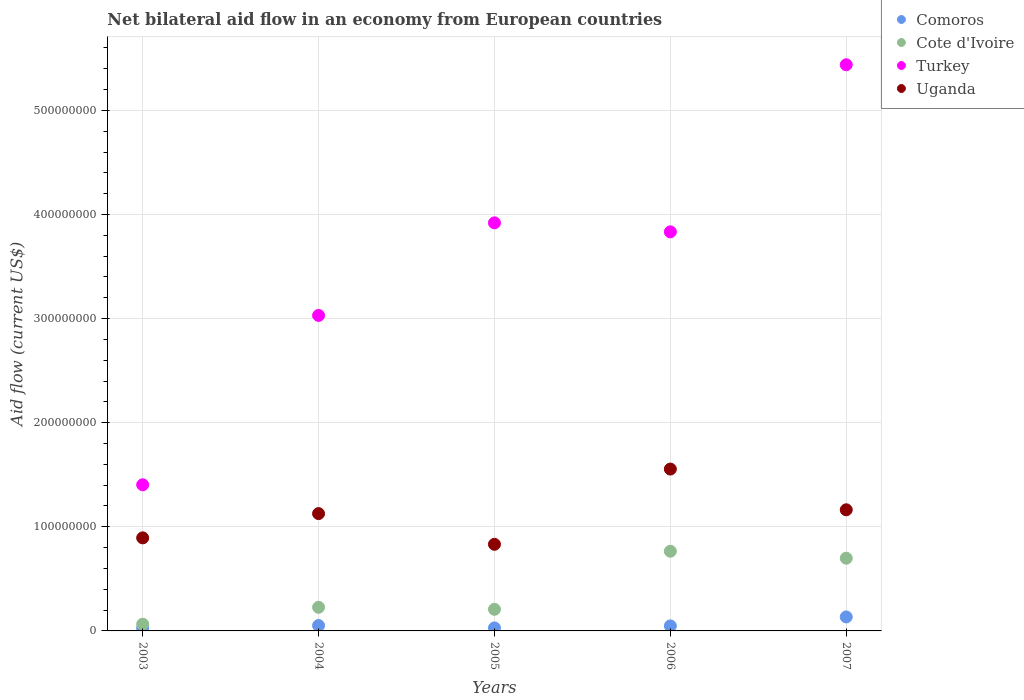What is the net bilateral aid flow in Cote d'Ivoire in 2003?
Make the answer very short. 6.45e+06. Across all years, what is the maximum net bilateral aid flow in Uganda?
Your answer should be compact. 1.55e+08. Across all years, what is the minimum net bilateral aid flow in Cote d'Ivoire?
Give a very brief answer. 6.45e+06. In which year was the net bilateral aid flow in Uganda maximum?
Your response must be concise. 2006. What is the total net bilateral aid flow in Turkey in the graph?
Your answer should be very brief. 1.76e+09. What is the difference between the net bilateral aid flow in Cote d'Ivoire in 2004 and that in 2006?
Provide a short and direct response. -5.38e+07. What is the difference between the net bilateral aid flow in Comoros in 2004 and the net bilateral aid flow in Turkey in 2003?
Ensure brevity in your answer.  -1.35e+08. What is the average net bilateral aid flow in Cote d'Ivoire per year?
Your answer should be compact. 3.93e+07. In the year 2005, what is the difference between the net bilateral aid flow in Turkey and net bilateral aid flow in Cote d'Ivoire?
Your answer should be compact. 3.71e+08. What is the ratio of the net bilateral aid flow in Cote d'Ivoire in 2004 to that in 2006?
Ensure brevity in your answer.  0.3. What is the difference between the highest and the second highest net bilateral aid flow in Cote d'Ivoire?
Make the answer very short. 6.69e+06. What is the difference between the highest and the lowest net bilateral aid flow in Turkey?
Ensure brevity in your answer.  4.03e+08. In how many years, is the net bilateral aid flow in Comoros greater than the average net bilateral aid flow in Comoros taken over all years?
Your answer should be compact. 1. Is it the case that in every year, the sum of the net bilateral aid flow in Comoros and net bilateral aid flow in Turkey  is greater than the sum of net bilateral aid flow in Cote d'Ivoire and net bilateral aid flow in Uganda?
Your response must be concise. Yes. Is the net bilateral aid flow in Comoros strictly greater than the net bilateral aid flow in Uganda over the years?
Your response must be concise. No. Is the net bilateral aid flow in Cote d'Ivoire strictly less than the net bilateral aid flow in Turkey over the years?
Provide a succinct answer. Yes. How many dotlines are there?
Offer a very short reply. 4. How many years are there in the graph?
Your answer should be compact. 5. What is the difference between two consecutive major ticks on the Y-axis?
Give a very brief answer. 1.00e+08. Are the values on the major ticks of Y-axis written in scientific E-notation?
Give a very brief answer. No. Does the graph contain any zero values?
Give a very brief answer. No. Where does the legend appear in the graph?
Keep it short and to the point. Top right. How are the legend labels stacked?
Keep it short and to the point. Vertical. What is the title of the graph?
Make the answer very short. Net bilateral aid flow in an economy from European countries. Does "Guatemala" appear as one of the legend labels in the graph?
Your response must be concise. No. What is the Aid flow (current US$) of Comoros in 2003?
Your answer should be very brief. 2.58e+06. What is the Aid flow (current US$) in Cote d'Ivoire in 2003?
Offer a terse response. 6.45e+06. What is the Aid flow (current US$) in Turkey in 2003?
Ensure brevity in your answer.  1.40e+08. What is the Aid flow (current US$) in Uganda in 2003?
Your response must be concise. 8.94e+07. What is the Aid flow (current US$) in Comoros in 2004?
Offer a terse response. 5.19e+06. What is the Aid flow (current US$) in Cote d'Ivoire in 2004?
Your answer should be compact. 2.27e+07. What is the Aid flow (current US$) in Turkey in 2004?
Keep it short and to the point. 3.03e+08. What is the Aid flow (current US$) in Uganda in 2004?
Offer a terse response. 1.13e+08. What is the Aid flow (current US$) of Comoros in 2005?
Ensure brevity in your answer.  2.88e+06. What is the Aid flow (current US$) of Cote d'Ivoire in 2005?
Offer a very short reply. 2.08e+07. What is the Aid flow (current US$) of Turkey in 2005?
Your response must be concise. 3.92e+08. What is the Aid flow (current US$) in Uganda in 2005?
Make the answer very short. 8.32e+07. What is the Aid flow (current US$) of Comoros in 2006?
Provide a succinct answer. 4.81e+06. What is the Aid flow (current US$) in Cote d'Ivoire in 2006?
Offer a very short reply. 7.65e+07. What is the Aid flow (current US$) of Turkey in 2006?
Offer a terse response. 3.83e+08. What is the Aid flow (current US$) of Uganda in 2006?
Your answer should be compact. 1.55e+08. What is the Aid flow (current US$) of Comoros in 2007?
Make the answer very short. 1.34e+07. What is the Aid flow (current US$) of Cote d'Ivoire in 2007?
Give a very brief answer. 6.98e+07. What is the Aid flow (current US$) of Turkey in 2007?
Provide a short and direct response. 5.44e+08. What is the Aid flow (current US$) of Uganda in 2007?
Ensure brevity in your answer.  1.16e+08. Across all years, what is the maximum Aid flow (current US$) of Comoros?
Provide a short and direct response. 1.34e+07. Across all years, what is the maximum Aid flow (current US$) in Cote d'Ivoire?
Keep it short and to the point. 7.65e+07. Across all years, what is the maximum Aid flow (current US$) in Turkey?
Provide a succinct answer. 5.44e+08. Across all years, what is the maximum Aid flow (current US$) of Uganda?
Offer a terse response. 1.55e+08. Across all years, what is the minimum Aid flow (current US$) of Comoros?
Your response must be concise. 2.58e+06. Across all years, what is the minimum Aid flow (current US$) in Cote d'Ivoire?
Provide a succinct answer. 6.45e+06. Across all years, what is the minimum Aid flow (current US$) of Turkey?
Provide a short and direct response. 1.40e+08. Across all years, what is the minimum Aid flow (current US$) in Uganda?
Ensure brevity in your answer.  8.32e+07. What is the total Aid flow (current US$) of Comoros in the graph?
Give a very brief answer. 2.89e+07. What is the total Aid flow (current US$) of Cote d'Ivoire in the graph?
Your response must be concise. 1.96e+08. What is the total Aid flow (current US$) of Turkey in the graph?
Ensure brevity in your answer.  1.76e+09. What is the total Aid flow (current US$) of Uganda in the graph?
Provide a short and direct response. 5.57e+08. What is the difference between the Aid flow (current US$) of Comoros in 2003 and that in 2004?
Keep it short and to the point. -2.61e+06. What is the difference between the Aid flow (current US$) in Cote d'Ivoire in 2003 and that in 2004?
Offer a very short reply. -1.62e+07. What is the difference between the Aid flow (current US$) of Turkey in 2003 and that in 2004?
Ensure brevity in your answer.  -1.63e+08. What is the difference between the Aid flow (current US$) in Uganda in 2003 and that in 2004?
Ensure brevity in your answer.  -2.33e+07. What is the difference between the Aid flow (current US$) in Comoros in 2003 and that in 2005?
Provide a succinct answer. -3.00e+05. What is the difference between the Aid flow (current US$) in Cote d'Ivoire in 2003 and that in 2005?
Give a very brief answer. -1.43e+07. What is the difference between the Aid flow (current US$) of Turkey in 2003 and that in 2005?
Provide a short and direct response. -2.52e+08. What is the difference between the Aid flow (current US$) of Uganda in 2003 and that in 2005?
Keep it short and to the point. 6.18e+06. What is the difference between the Aid flow (current US$) of Comoros in 2003 and that in 2006?
Keep it short and to the point. -2.23e+06. What is the difference between the Aid flow (current US$) in Cote d'Ivoire in 2003 and that in 2006?
Offer a terse response. -7.01e+07. What is the difference between the Aid flow (current US$) in Turkey in 2003 and that in 2006?
Give a very brief answer. -2.43e+08. What is the difference between the Aid flow (current US$) in Uganda in 2003 and that in 2006?
Your answer should be compact. -6.61e+07. What is the difference between the Aid flow (current US$) in Comoros in 2003 and that in 2007?
Ensure brevity in your answer.  -1.09e+07. What is the difference between the Aid flow (current US$) in Cote d'Ivoire in 2003 and that in 2007?
Offer a terse response. -6.34e+07. What is the difference between the Aid flow (current US$) of Turkey in 2003 and that in 2007?
Make the answer very short. -4.03e+08. What is the difference between the Aid flow (current US$) of Uganda in 2003 and that in 2007?
Your response must be concise. -2.70e+07. What is the difference between the Aid flow (current US$) in Comoros in 2004 and that in 2005?
Your response must be concise. 2.31e+06. What is the difference between the Aid flow (current US$) of Cote d'Ivoire in 2004 and that in 2005?
Your answer should be very brief. 1.94e+06. What is the difference between the Aid flow (current US$) in Turkey in 2004 and that in 2005?
Your answer should be very brief. -8.89e+07. What is the difference between the Aid flow (current US$) in Uganda in 2004 and that in 2005?
Offer a very short reply. 2.95e+07. What is the difference between the Aid flow (current US$) of Cote d'Ivoire in 2004 and that in 2006?
Give a very brief answer. -5.38e+07. What is the difference between the Aid flow (current US$) of Turkey in 2004 and that in 2006?
Your answer should be compact. -8.03e+07. What is the difference between the Aid flow (current US$) of Uganda in 2004 and that in 2006?
Keep it short and to the point. -4.28e+07. What is the difference between the Aid flow (current US$) of Comoros in 2004 and that in 2007?
Give a very brief answer. -8.25e+06. What is the difference between the Aid flow (current US$) of Cote d'Ivoire in 2004 and that in 2007?
Make the answer very short. -4.72e+07. What is the difference between the Aid flow (current US$) in Turkey in 2004 and that in 2007?
Offer a very short reply. -2.41e+08. What is the difference between the Aid flow (current US$) of Uganda in 2004 and that in 2007?
Your answer should be very brief. -3.66e+06. What is the difference between the Aid flow (current US$) in Comoros in 2005 and that in 2006?
Offer a very short reply. -1.93e+06. What is the difference between the Aid flow (current US$) of Cote d'Ivoire in 2005 and that in 2006?
Provide a short and direct response. -5.58e+07. What is the difference between the Aid flow (current US$) of Turkey in 2005 and that in 2006?
Give a very brief answer. 8.64e+06. What is the difference between the Aid flow (current US$) in Uganda in 2005 and that in 2006?
Offer a very short reply. -7.23e+07. What is the difference between the Aid flow (current US$) in Comoros in 2005 and that in 2007?
Give a very brief answer. -1.06e+07. What is the difference between the Aid flow (current US$) in Cote d'Ivoire in 2005 and that in 2007?
Make the answer very short. -4.91e+07. What is the difference between the Aid flow (current US$) in Turkey in 2005 and that in 2007?
Your answer should be very brief. -1.52e+08. What is the difference between the Aid flow (current US$) in Uganda in 2005 and that in 2007?
Offer a very short reply. -3.32e+07. What is the difference between the Aid flow (current US$) of Comoros in 2006 and that in 2007?
Your answer should be very brief. -8.63e+06. What is the difference between the Aid flow (current US$) in Cote d'Ivoire in 2006 and that in 2007?
Your answer should be very brief. 6.69e+06. What is the difference between the Aid flow (current US$) of Turkey in 2006 and that in 2007?
Provide a succinct answer. -1.60e+08. What is the difference between the Aid flow (current US$) in Uganda in 2006 and that in 2007?
Your answer should be compact. 3.91e+07. What is the difference between the Aid flow (current US$) in Comoros in 2003 and the Aid flow (current US$) in Cote d'Ivoire in 2004?
Keep it short and to the point. -2.01e+07. What is the difference between the Aid flow (current US$) of Comoros in 2003 and the Aid flow (current US$) of Turkey in 2004?
Give a very brief answer. -3.00e+08. What is the difference between the Aid flow (current US$) of Comoros in 2003 and the Aid flow (current US$) of Uganda in 2004?
Give a very brief answer. -1.10e+08. What is the difference between the Aid flow (current US$) of Cote d'Ivoire in 2003 and the Aid flow (current US$) of Turkey in 2004?
Give a very brief answer. -2.97e+08. What is the difference between the Aid flow (current US$) in Cote d'Ivoire in 2003 and the Aid flow (current US$) in Uganda in 2004?
Make the answer very short. -1.06e+08. What is the difference between the Aid flow (current US$) in Turkey in 2003 and the Aid flow (current US$) in Uganda in 2004?
Provide a short and direct response. 2.77e+07. What is the difference between the Aid flow (current US$) of Comoros in 2003 and the Aid flow (current US$) of Cote d'Ivoire in 2005?
Make the answer very short. -1.82e+07. What is the difference between the Aid flow (current US$) of Comoros in 2003 and the Aid flow (current US$) of Turkey in 2005?
Give a very brief answer. -3.89e+08. What is the difference between the Aid flow (current US$) of Comoros in 2003 and the Aid flow (current US$) of Uganda in 2005?
Provide a succinct answer. -8.06e+07. What is the difference between the Aid flow (current US$) of Cote d'Ivoire in 2003 and the Aid flow (current US$) of Turkey in 2005?
Give a very brief answer. -3.86e+08. What is the difference between the Aid flow (current US$) of Cote d'Ivoire in 2003 and the Aid flow (current US$) of Uganda in 2005?
Your answer should be compact. -7.68e+07. What is the difference between the Aid flow (current US$) in Turkey in 2003 and the Aid flow (current US$) in Uganda in 2005?
Offer a very short reply. 5.72e+07. What is the difference between the Aid flow (current US$) of Comoros in 2003 and the Aid flow (current US$) of Cote d'Ivoire in 2006?
Offer a very short reply. -7.40e+07. What is the difference between the Aid flow (current US$) of Comoros in 2003 and the Aid flow (current US$) of Turkey in 2006?
Offer a terse response. -3.81e+08. What is the difference between the Aid flow (current US$) in Comoros in 2003 and the Aid flow (current US$) in Uganda in 2006?
Your response must be concise. -1.53e+08. What is the difference between the Aid flow (current US$) in Cote d'Ivoire in 2003 and the Aid flow (current US$) in Turkey in 2006?
Provide a succinct answer. -3.77e+08. What is the difference between the Aid flow (current US$) in Cote d'Ivoire in 2003 and the Aid flow (current US$) in Uganda in 2006?
Keep it short and to the point. -1.49e+08. What is the difference between the Aid flow (current US$) of Turkey in 2003 and the Aid flow (current US$) of Uganda in 2006?
Provide a short and direct response. -1.51e+07. What is the difference between the Aid flow (current US$) of Comoros in 2003 and the Aid flow (current US$) of Cote d'Ivoire in 2007?
Keep it short and to the point. -6.73e+07. What is the difference between the Aid flow (current US$) in Comoros in 2003 and the Aid flow (current US$) in Turkey in 2007?
Provide a short and direct response. -5.41e+08. What is the difference between the Aid flow (current US$) in Comoros in 2003 and the Aid flow (current US$) in Uganda in 2007?
Offer a terse response. -1.14e+08. What is the difference between the Aid flow (current US$) in Cote d'Ivoire in 2003 and the Aid flow (current US$) in Turkey in 2007?
Provide a succinct answer. -5.37e+08. What is the difference between the Aid flow (current US$) in Cote d'Ivoire in 2003 and the Aid flow (current US$) in Uganda in 2007?
Provide a short and direct response. -1.10e+08. What is the difference between the Aid flow (current US$) of Turkey in 2003 and the Aid flow (current US$) of Uganda in 2007?
Ensure brevity in your answer.  2.40e+07. What is the difference between the Aid flow (current US$) of Comoros in 2004 and the Aid flow (current US$) of Cote d'Ivoire in 2005?
Offer a very short reply. -1.56e+07. What is the difference between the Aid flow (current US$) of Comoros in 2004 and the Aid flow (current US$) of Turkey in 2005?
Make the answer very short. -3.87e+08. What is the difference between the Aid flow (current US$) in Comoros in 2004 and the Aid flow (current US$) in Uganda in 2005?
Your response must be concise. -7.80e+07. What is the difference between the Aid flow (current US$) of Cote d'Ivoire in 2004 and the Aid flow (current US$) of Turkey in 2005?
Give a very brief answer. -3.69e+08. What is the difference between the Aid flow (current US$) of Cote d'Ivoire in 2004 and the Aid flow (current US$) of Uganda in 2005?
Your answer should be compact. -6.05e+07. What is the difference between the Aid flow (current US$) of Turkey in 2004 and the Aid flow (current US$) of Uganda in 2005?
Ensure brevity in your answer.  2.20e+08. What is the difference between the Aid flow (current US$) of Comoros in 2004 and the Aid flow (current US$) of Cote d'Ivoire in 2006?
Give a very brief answer. -7.14e+07. What is the difference between the Aid flow (current US$) of Comoros in 2004 and the Aid flow (current US$) of Turkey in 2006?
Keep it short and to the point. -3.78e+08. What is the difference between the Aid flow (current US$) in Comoros in 2004 and the Aid flow (current US$) in Uganda in 2006?
Provide a succinct answer. -1.50e+08. What is the difference between the Aid flow (current US$) in Cote d'Ivoire in 2004 and the Aid flow (current US$) in Turkey in 2006?
Your response must be concise. -3.61e+08. What is the difference between the Aid flow (current US$) in Cote d'Ivoire in 2004 and the Aid flow (current US$) in Uganda in 2006?
Give a very brief answer. -1.33e+08. What is the difference between the Aid flow (current US$) of Turkey in 2004 and the Aid flow (current US$) of Uganda in 2006?
Offer a terse response. 1.48e+08. What is the difference between the Aid flow (current US$) of Comoros in 2004 and the Aid flow (current US$) of Cote d'Ivoire in 2007?
Offer a very short reply. -6.47e+07. What is the difference between the Aid flow (current US$) in Comoros in 2004 and the Aid flow (current US$) in Turkey in 2007?
Your answer should be compact. -5.39e+08. What is the difference between the Aid flow (current US$) in Comoros in 2004 and the Aid flow (current US$) in Uganda in 2007?
Ensure brevity in your answer.  -1.11e+08. What is the difference between the Aid flow (current US$) of Cote d'Ivoire in 2004 and the Aid flow (current US$) of Turkey in 2007?
Provide a short and direct response. -5.21e+08. What is the difference between the Aid flow (current US$) of Cote d'Ivoire in 2004 and the Aid flow (current US$) of Uganda in 2007?
Provide a succinct answer. -9.37e+07. What is the difference between the Aid flow (current US$) in Turkey in 2004 and the Aid flow (current US$) in Uganda in 2007?
Offer a very short reply. 1.87e+08. What is the difference between the Aid flow (current US$) of Comoros in 2005 and the Aid flow (current US$) of Cote d'Ivoire in 2006?
Keep it short and to the point. -7.37e+07. What is the difference between the Aid flow (current US$) in Comoros in 2005 and the Aid flow (current US$) in Turkey in 2006?
Offer a very short reply. -3.80e+08. What is the difference between the Aid flow (current US$) of Comoros in 2005 and the Aid flow (current US$) of Uganda in 2006?
Your answer should be very brief. -1.53e+08. What is the difference between the Aid flow (current US$) of Cote d'Ivoire in 2005 and the Aid flow (current US$) of Turkey in 2006?
Your answer should be compact. -3.63e+08. What is the difference between the Aid flow (current US$) in Cote d'Ivoire in 2005 and the Aid flow (current US$) in Uganda in 2006?
Offer a terse response. -1.35e+08. What is the difference between the Aid flow (current US$) of Turkey in 2005 and the Aid flow (current US$) of Uganda in 2006?
Ensure brevity in your answer.  2.37e+08. What is the difference between the Aid flow (current US$) in Comoros in 2005 and the Aid flow (current US$) in Cote d'Ivoire in 2007?
Your answer should be very brief. -6.70e+07. What is the difference between the Aid flow (current US$) in Comoros in 2005 and the Aid flow (current US$) in Turkey in 2007?
Make the answer very short. -5.41e+08. What is the difference between the Aid flow (current US$) in Comoros in 2005 and the Aid flow (current US$) in Uganda in 2007?
Give a very brief answer. -1.13e+08. What is the difference between the Aid flow (current US$) in Cote d'Ivoire in 2005 and the Aid flow (current US$) in Turkey in 2007?
Give a very brief answer. -5.23e+08. What is the difference between the Aid flow (current US$) in Cote d'Ivoire in 2005 and the Aid flow (current US$) in Uganda in 2007?
Provide a succinct answer. -9.56e+07. What is the difference between the Aid flow (current US$) in Turkey in 2005 and the Aid flow (current US$) in Uganda in 2007?
Provide a succinct answer. 2.76e+08. What is the difference between the Aid flow (current US$) of Comoros in 2006 and the Aid flow (current US$) of Cote d'Ivoire in 2007?
Your response must be concise. -6.50e+07. What is the difference between the Aid flow (current US$) in Comoros in 2006 and the Aid flow (current US$) in Turkey in 2007?
Provide a succinct answer. -5.39e+08. What is the difference between the Aid flow (current US$) of Comoros in 2006 and the Aid flow (current US$) of Uganda in 2007?
Provide a short and direct response. -1.12e+08. What is the difference between the Aid flow (current US$) of Cote d'Ivoire in 2006 and the Aid flow (current US$) of Turkey in 2007?
Provide a succinct answer. -4.67e+08. What is the difference between the Aid flow (current US$) in Cote d'Ivoire in 2006 and the Aid flow (current US$) in Uganda in 2007?
Ensure brevity in your answer.  -3.98e+07. What is the difference between the Aid flow (current US$) in Turkey in 2006 and the Aid flow (current US$) in Uganda in 2007?
Your answer should be compact. 2.67e+08. What is the average Aid flow (current US$) of Comoros per year?
Ensure brevity in your answer.  5.78e+06. What is the average Aid flow (current US$) of Cote d'Ivoire per year?
Give a very brief answer. 3.93e+07. What is the average Aid flow (current US$) in Turkey per year?
Provide a succinct answer. 3.53e+08. What is the average Aid flow (current US$) of Uganda per year?
Your answer should be compact. 1.11e+08. In the year 2003, what is the difference between the Aid flow (current US$) of Comoros and Aid flow (current US$) of Cote d'Ivoire?
Give a very brief answer. -3.87e+06. In the year 2003, what is the difference between the Aid flow (current US$) in Comoros and Aid flow (current US$) in Turkey?
Your answer should be compact. -1.38e+08. In the year 2003, what is the difference between the Aid flow (current US$) of Comoros and Aid flow (current US$) of Uganda?
Keep it short and to the point. -8.68e+07. In the year 2003, what is the difference between the Aid flow (current US$) of Cote d'Ivoire and Aid flow (current US$) of Turkey?
Your response must be concise. -1.34e+08. In the year 2003, what is the difference between the Aid flow (current US$) in Cote d'Ivoire and Aid flow (current US$) in Uganda?
Your answer should be compact. -8.29e+07. In the year 2003, what is the difference between the Aid flow (current US$) of Turkey and Aid flow (current US$) of Uganda?
Give a very brief answer. 5.10e+07. In the year 2004, what is the difference between the Aid flow (current US$) in Comoros and Aid flow (current US$) in Cote d'Ivoire?
Your response must be concise. -1.75e+07. In the year 2004, what is the difference between the Aid flow (current US$) in Comoros and Aid flow (current US$) in Turkey?
Offer a very short reply. -2.98e+08. In the year 2004, what is the difference between the Aid flow (current US$) of Comoros and Aid flow (current US$) of Uganda?
Offer a terse response. -1.08e+08. In the year 2004, what is the difference between the Aid flow (current US$) of Cote d'Ivoire and Aid flow (current US$) of Turkey?
Make the answer very short. -2.80e+08. In the year 2004, what is the difference between the Aid flow (current US$) of Cote d'Ivoire and Aid flow (current US$) of Uganda?
Give a very brief answer. -9.00e+07. In the year 2004, what is the difference between the Aid flow (current US$) of Turkey and Aid flow (current US$) of Uganda?
Provide a succinct answer. 1.90e+08. In the year 2005, what is the difference between the Aid flow (current US$) in Comoros and Aid flow (current US$) in Cote d'Ivoire?
Your answer should be very brief. -1.79e+07. In the year 2005, what is the difference between the Aid flow (current US$) of Comoros and Aid flow (current US$) of Turkey?
Offer a terse response. -3.89e+08. In the year 2005, what is the difference between the Aid flow (current US$) in Comoros and Aid flow (current US$) in Uganda?
Your answer should be very brief. -8.03e+07. In the year 2005, what is the difference between the Aid flow (current US$) of Cote d'Ivoire and Aid flow (current US$) of Turkey?
Provide a short and direct response. -3.71e+08. In the year 2005, what is the difference between the Aid flow (current US$) of Cote d'Ivoire and Aid flow (current US$) of Uganda?
Make the answer very short. -6.24e+07. In the year 2005, what is the difference between the Aid flow (current US$) in Turkey and Aid flow (current US$) in Uganda?
Make the answer very short. 3.09e+08. In the year 2006, what is the difference between the Aid flow (current US$) in Comoros and Aid flow (current US$) in Cote d'Ivoire?
Ensure brevity in your answer.  -7.17e+07. In the year 2006, what is the difference between the Aid flow (current US$) in Comoros and Aid flow (current US$) in Turkey?
Offer a very short reply. -3.79e+08. In the year 2006, what is the difference between the Aid flow (current US$) in Comoros and Aid flow (current US$) in Uganda?
Make the answer very short. -1.51e+08. In the year 2006, what is the difference between the Aid flow (current US$) in Cote d'Ivoire and Aid flow (current US$) in Turkey?
Your response must be concise. -3.07e+08. In the year 2006, what is the difference between the Aid flow (current US$) in Cote d'Ivoire and Aid flow (current US$) in Uganda?
Provide a succinct answer. -7.89e+07. In the year 2006, what is the difference between the Aid flow (current US$) of Turkey and Aid flow (current US$) of Uganda?
Give a very brief answer. 2.28e+08. In the year 2007, what is the difference between the Aid flow (current US$) in Comoros and Aid flow (current US$) in Cote d'Ivoire?
Your response must be concise. -5.64e+07. In the year 2007, what is the difference between the Aid flow (current US$) in Comoros and Aid flow (current US$) in Turkey?
Keep it short and to the point. -5.30e+08. In the year 2007, what is the difference between the Aid flow (current US$) in Comoros and Aid flow (current US$) in Uganda?
Offer a terse response. -1.03e+08. In the year 2007, what is the difference between the Aid flow (current US$) of Cote d'Ivoire and Aid flow (current US$) of Turkey?
Give a very brief answer. -4.74e+08. In the year 2007, what is the difference between the Aid flow (current US$) in Cote d'Ivoire and Aid flow (current US$) in Uganda?
Provide a succinct answer. -4.65e+07. In the year 2007, what is the difference between the Aid flow (current US$) of Turkey and Aid flow (current US$) of Uganda?
Your response must be concise. 4.27e+08. What is the ratio of the Aid flow (current US$) in Comoros in 2003 to that in 2004?
Provide a short and direct response. 0.5. What is the ratio of the Aid flow (current US$) of Cote d'Ivoire in 2003 to that in 2004?
Your answer should be very brief. 0.28. What is the ratio of the Aid flow (current US$) of Turkey in 2003 to that in 2004?
Provide a succinct answer. 0.46. What is the ratio of the Aid flow (current US$) of Uganda in 2003 to that in 2004?
Your response must be concise. 0.79. What is the ratio of the Aid flow (current US$) in Comoros in 2003 to that in 2005?
Offer a terse response. 0.9. What is the ratio of the Aid flow (current US$) of Cote d'Ivoire in 2003 to that in 2005?
Provide a short and direct response. 0.31. What is the ratio of the Aid flow (current US$) of Turkey in 2003 to that in 2005?
Your response must be concise. 0.36. What is the ratio of the Aid flow (current US$) of Uganda in 2003 to that in 2005?
Keep it short and to the point. 1.07. What is the ratio of the Aid flow (current US$) of Comoros in 2003 to that in 2006?
Give a very brief answer. 0.54. What is the ratio of the Aid flow (current US$) of Cote d'Ivoire in 2003 to that in 2006?
Ensure brevity in your answer.  0.08. What is the ratio of the Aid flow (current US$) of Turkey in 2003 to that in 2006?
Your answer should be very brief. 0.37. What is the ratio of the Aid flow (current US$) of Uganda in 2003 to that in 2006?
Your answer should be compact. 0.57. What is the ratio of the Aid flow (current US$) in Comoros in 2003 to that in 2007?
Keep it short and to the point. 0.19. What is the ratio of the Aid flow (current US$) of Cote d'Ivoire in 2003 to that in 2007?
Your answer should be compact. 0.09. What is the ratio of the Aid flow (current US$) in Turkey in 2003 to that in 2007?
Offer a terse response. 0.26. What is the ratio of the Aid flow (current US$) in Uganda in 2003 to that in 2007?
Ensure brevity in your answer.  0.77. What is the ratio of the Aid flow (current US$) in Comoros in 2004 to that in 2005?
Provide a succinct answer. 1.8. What is the ratio of the Aid flow (current US$) of Cote d'Ivoire in 2004 to that in 2005?
Your answer should be very brief. 1.09. What is the ratio of the Aid flow (current US$) of Turkey in 2004 to that in 2005?
Your answer should be very brief. 0.77. What is the ratio of the Aid flow (current US$) of Uganda in 2004 to that in 2005?
Give a very brief answer. 1.35. What is the ratio of the Aid flow (current US$) of Comoros in 2004 to that in 2006?
Give a very brief answer. 1.08. What is the ratio of the Aid flow (current US$) of Cote d'Ivoire in 2004 to that in 2006?
Keep it short and to the point. 0.3. What is the ratio of the Aid flow (current US$) in Turkey in 2004 to that in 2006?
Provide a short and direct response. 0.79. What is the ratio of the Aid flow (current US$) of Uganda in 2004 to that in 2006?
Make the answer very short. 0.72. What is the ratio of the Aid flow (current US$) in Comoros in 2004 to that in 2007?
Your response must be concise. 0.39. What is the ratio of the Aid flow (current US$) of Cote d'Ivoire in 2004 to that in 2007?
Provide a short and direct response. 0.32. What is the ratio of the Aid flow (current US$) of Turkey in 2004 to that in 2007?
Offer a very short reply. 0.56. What is the ratio of the Aid flow (current US$) of Uganda in 2004 to that in 2007?
Your answer should be very brief. 0.97. What is the ratio of the Aid flow (current US$) of Comoros in 2005 to that in 2006?
Offer a terse response. 0.6. What is the ratio of the Aid flow (current US$) of Cote d'Ivoire in 2005 to that in 2006?
Offer a very short reply. 0.27. What is the ratio of the Aid flow (current US$) in Turkey in 2005 to that in 2006?
Provide a succinct answer. 1.02. What is the ratio of the Aid flow (current US$) in Uganda in 2005 to that in 2006?
Your response must be concise. 0.54. What is the ratio of the Aid flow (current US$) of Comoros in 2005 to that in 2007?
Your answer should be compact. 0.21. What is the ratio of the Aid flow (current US$) in Cote d'Ivoire in 2005 to that in 2007?
Ensure brevity in your answer.  0.3. What is the ratio of the Aid flow (current US$) of Turkey in 2005 to that in 2007?
Give a very brief answer. 0.72. What is the ratio of the Aid flow (current US$) in Uganda in 2005 to that in 2007?
Offer a terse response. 0.72. What is the ratio of the Aid flow (current US$) in Comoros in 2006 to that in 2007?
Your response must be concise. 0.36. What is the ratio of the Aid flow (current US$) of Cote d'Ivoire in 2006 to that in 2007?
Offer a very short reply. 1.1. What is the ratio of the Aid flow (current US$) of Turkey in 2006 to that in 2007?
Your response must be concise. 0.7. What is the ratio of the Aid flow (current US$) in Uganda in 2006 to that in 2007?
Offer a terse response. 1.34. What is the difference between the highest and the second highest Aid flow (current US$) of Comoros?
Offer a terse response. 8.25e+06. What is the difference between the highest and the second highest Aid flow (current US$) of Cote d'Ivoire?
Keep it short and to the point. 6.69e+06. What is the difference between the highest and the second highest Aid flow (current US$) of Turkey?
Make the answer very short. 1.52e+08. What is the difference between the highest and the second highest Aid flow (current US$) of Uganda?
Make the answer very short. 3.91e+07. What is the difference between the highest and the lowest Aid flow (current US$) in Comoros?
Your answer should be very brief. 1.09e+07. What is the difference between the highest and the lowest Aid flow (current US$) of Cote d'Ivoire?
Offer a terse response. 7.01e+07. What is the difference between the highest and the lowest Aid flow (current US$) in Turkey?
Your response must be concise. 4.03e+08. What is the difference between the highest and the lowest Aid flow (current US$) of Uganda?
Provide a short and direct response. 7.23e+07. 